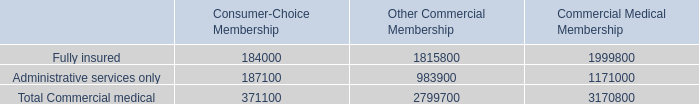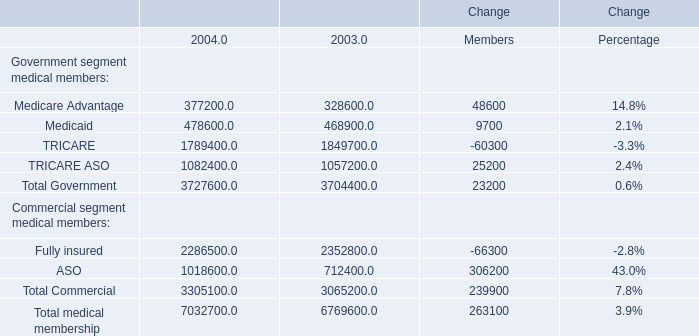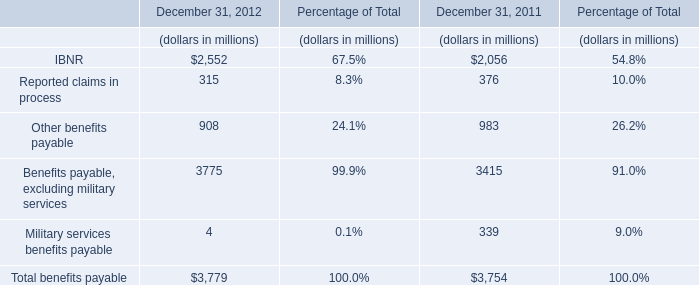what is the value of the total premiums and aso fees , in billions? 
Computations: (((50.1 * 100) / 0.4) / 1000)
Answer: 12.525. 